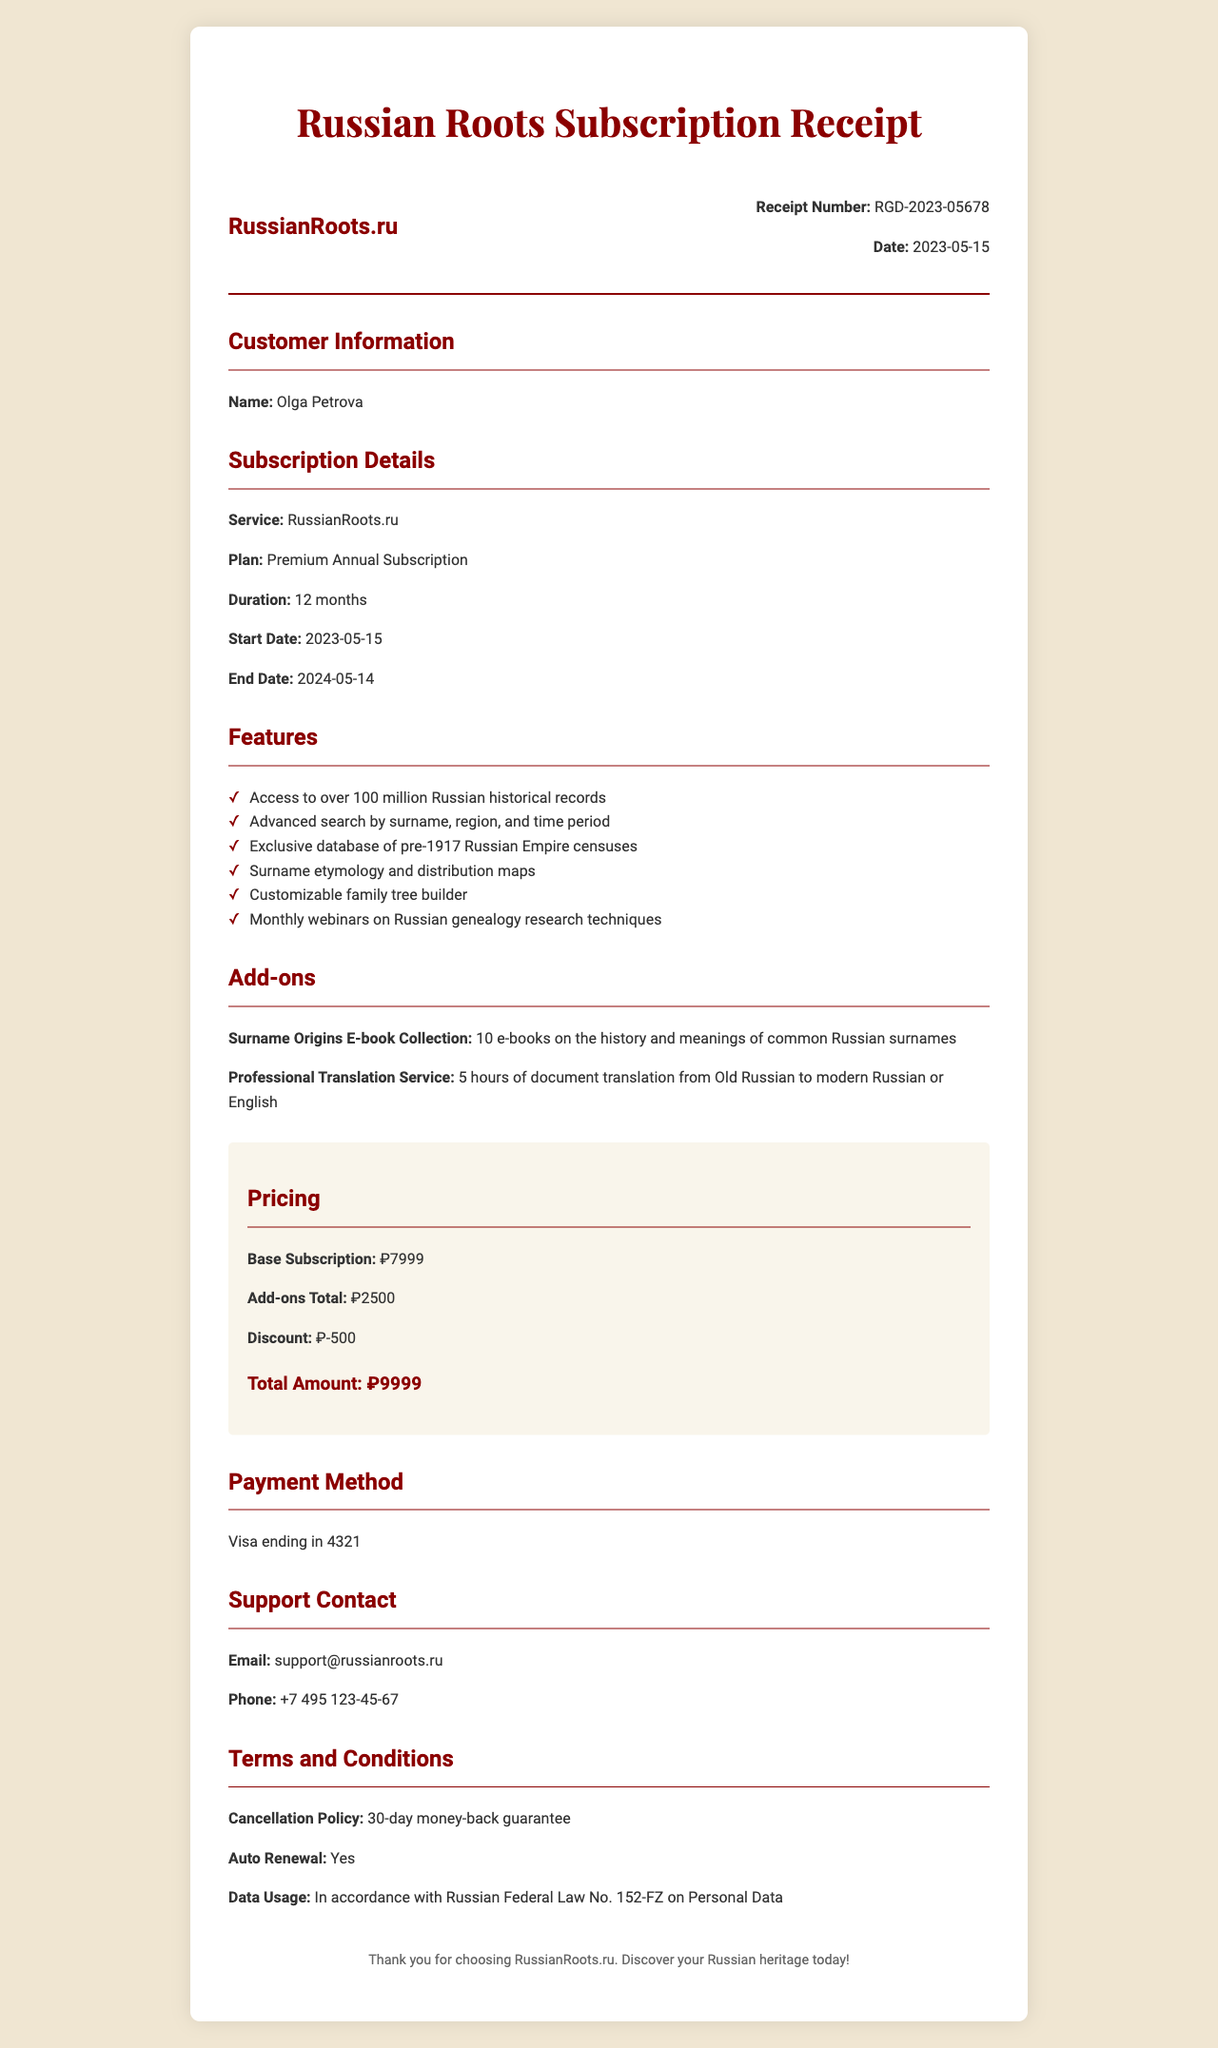What is the receipt number? The receipt number is specifically mentioned in the document, allowing for easy identification of the transaction.
Answer: RGD-2023-05678 What is the subscription start date? The subscription start date is clearly stated under the subscription details section of the receipt.
Answer: 2023-05-15 How long is the subscription valid? The duration of the subscription is specified in months and indicates the period the user can access the service.
Answer: 12 months What features are included in the subscription? The features listed provide insight into the benefits included in the subscription, showing the value offered.
Answer: Access to over 100 million Russian historical records What is the total amount paid for the subscription? The total amount displayed in the pricing section summarizes the complete cost after any discounts.
Answer: 9999 Is there a cancellation policy? The presence of a cancellation policy is important for understanding the terms under which the customer can discontinue service.
Answer: 30-day money-back guarantee What is the auto-renewal status of the subscription? Knowing whether the subscription will automatically renew helps the customer manage their future payments.
Answer: Yes What is the name of the add-on relating to surnames? The specific names of add-ons provide clarity on additional resources the customer has access to.
Answer: Surname Origins E-book Collection What is the payment method used for the subscription? The payment method helps verify how the transaction was processed.
Answer: Visa ending in 4321 